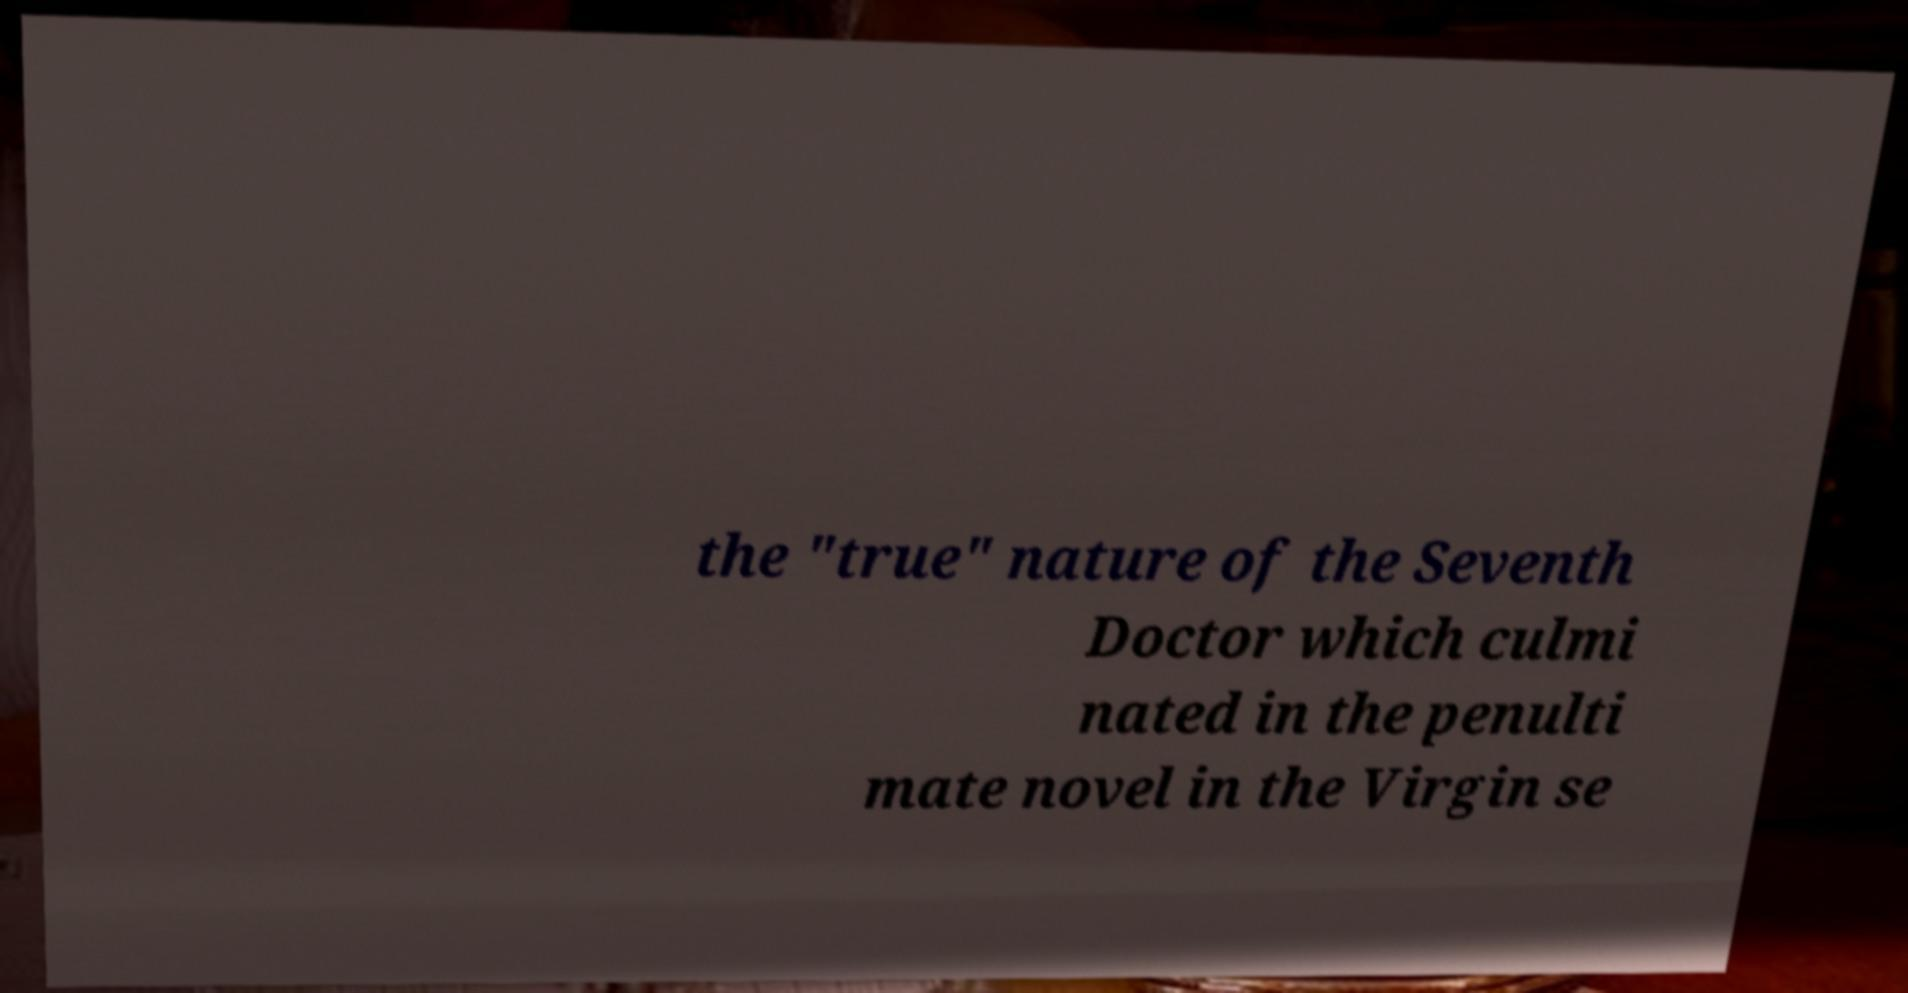What messages or text are displayed in this image? I need them in a readable, typed format. the "true" nature of the Seventh Doctor which culmi nated in the penulti mate novel in the Virgin se 